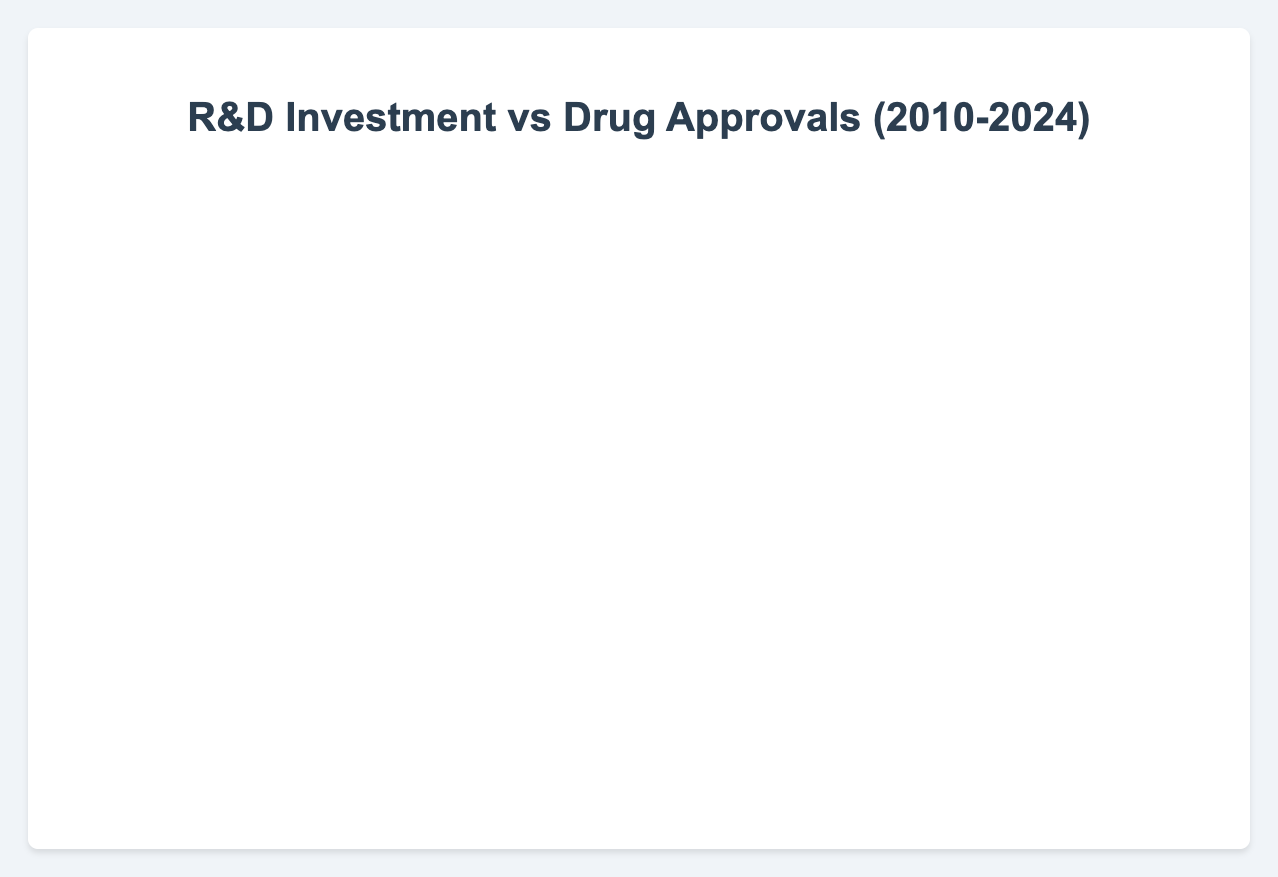What's the projected drug approval rate for Johnson & Johnson in 2024? The figure shows the drug approval rate for Johnson & Johnson in 2024 as a data point. Simply locate the point for Johnson & Johnson and read the value on the y-axis corresponding to 2024.
Answer: 42 Which company had the highest R&D investment in 2019? By identifying the data points for each company in 2019 on the x-axis, which represents R&D investment, we can compare the values. Johnson & Johnson's investment is highest compared to Pfizer and Merck & Co.
Answer: Johnson & Johnson In what year did Pfizer have the most drug approvals? By observing the trend for Pfizer over the years in terms of drug approvals on the y-axis, we see that the highest point is reached in 2019.
Answer: 2019 Compare the R&D investment trends for Merck & Co. and Johnson & Johnson from 2020 to 2024. From 2020 to 2024, Johnson & Johnson's R&D investment increases consistently, while Merck & Co. also shows a steady increase but starts from a lower base. Johnson & Johnson's investments are consistently higher.
Answer: Johnson & Johnson's investments are higher and increase steadily, while Merck & Co.'s investments also increase but less significantly How many more drug approvals did Johnson & Johnson have in 2023 compared to 2020? Find the values for drug approvals by Johnson & Johnson in 2023 (40) and 2020 (34), then subtract the 2020 value from the 2023 value (40 - 34).
Answer: 6 What was the total R&D investment by Pfizer between 2010 and 2019? Sum the R&D investments of Pfizer from 2010 to 2019: 7600 + 7700 + 7800 + 7900 + 8000 + 8200 + 8400 + 8600 + 8800 + 9000 = 82000 million USD.
Answer: 82000 million USD By how much did Merck & Co.’s drug approvals increase from 2015 to 2024? Identify Merck & Co.'s drug approvals in 2015 (18) and 2024 (31), then calculate the difference (31 - 18).
Answer: 13 Which company had a stable increase in both R&D investment and drug approvals over the years shown? Johnson & Johnson shows a consistent upward trend both in R&D investments and drug approvals from 2020 to 2024 when compared to Pfizer and Merck & Co.
Answer: Johnson & Johnson Describe the visual trend for Merck & Co.'s drug approvals from 2015 to 2024. Visually, Merck & Co.'s drug approvals increase somewhat linearly from 18 in 2015 to 31 in 2024, indicating steady growth.
Answer: Steadily increasing 